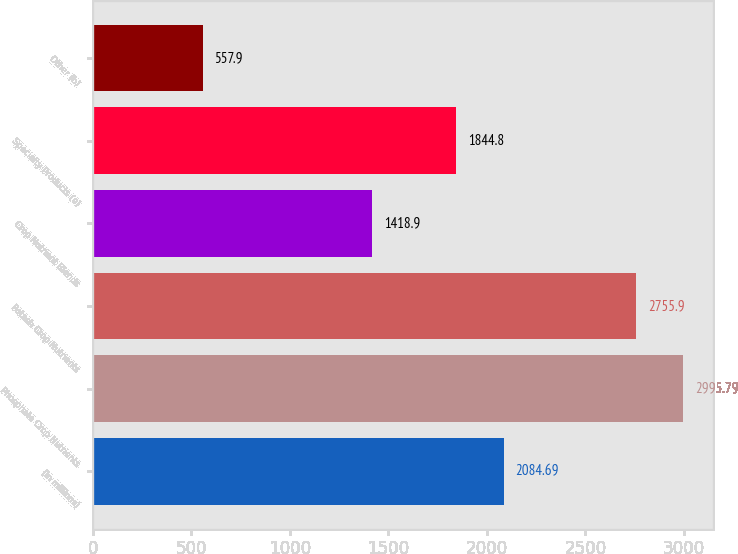Convert chart. <chart><loc_0><loc_0><loc_500><loc_500><bar_chart><fcel>(in millions)<fcel>Phosphate Crop Nutrients<fcel>Potash Crop Nutrients<fcel>Crop Nutrient Blends<fcel>Specialty Products (a)<fcel>Other (b)<nl><fcel>2084.69<fcel>2995.79<fcel>2755.9<fcel>1418.9<fcel>1844.8<fcel>557.9<nl></chart> 